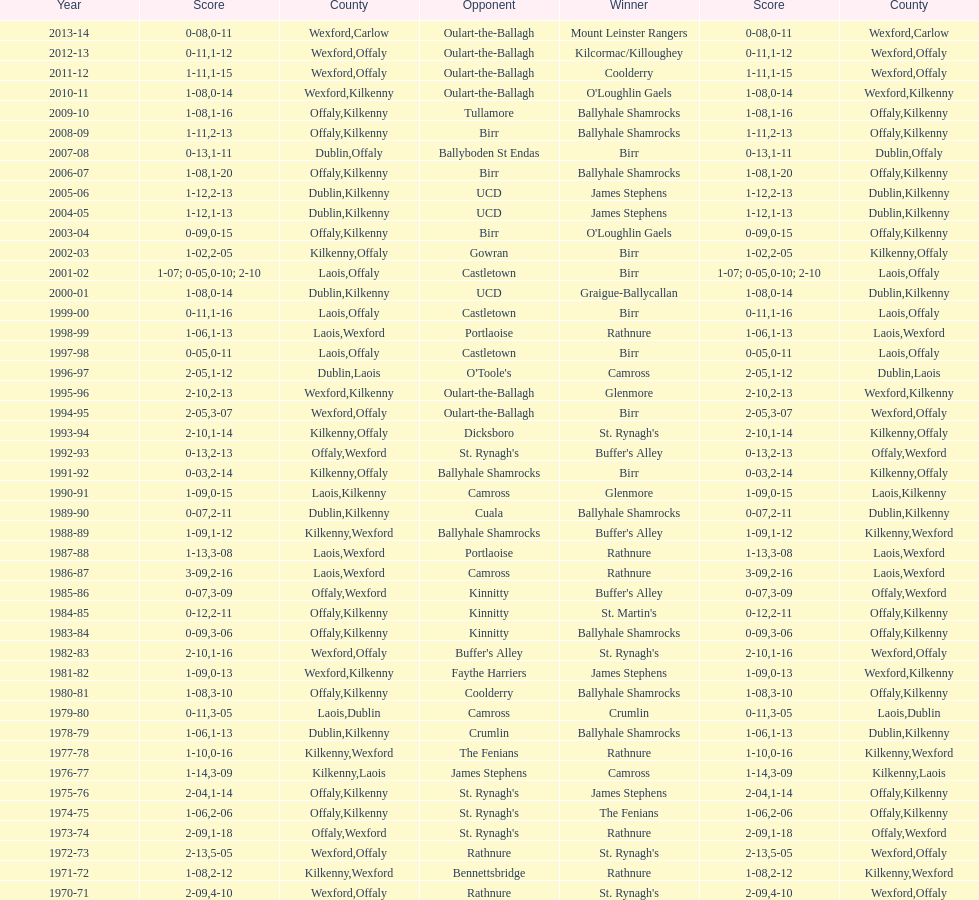Which team won the leinster senior club hurling championships previous to the last time birr won? Ballyhale Shamrocks. 